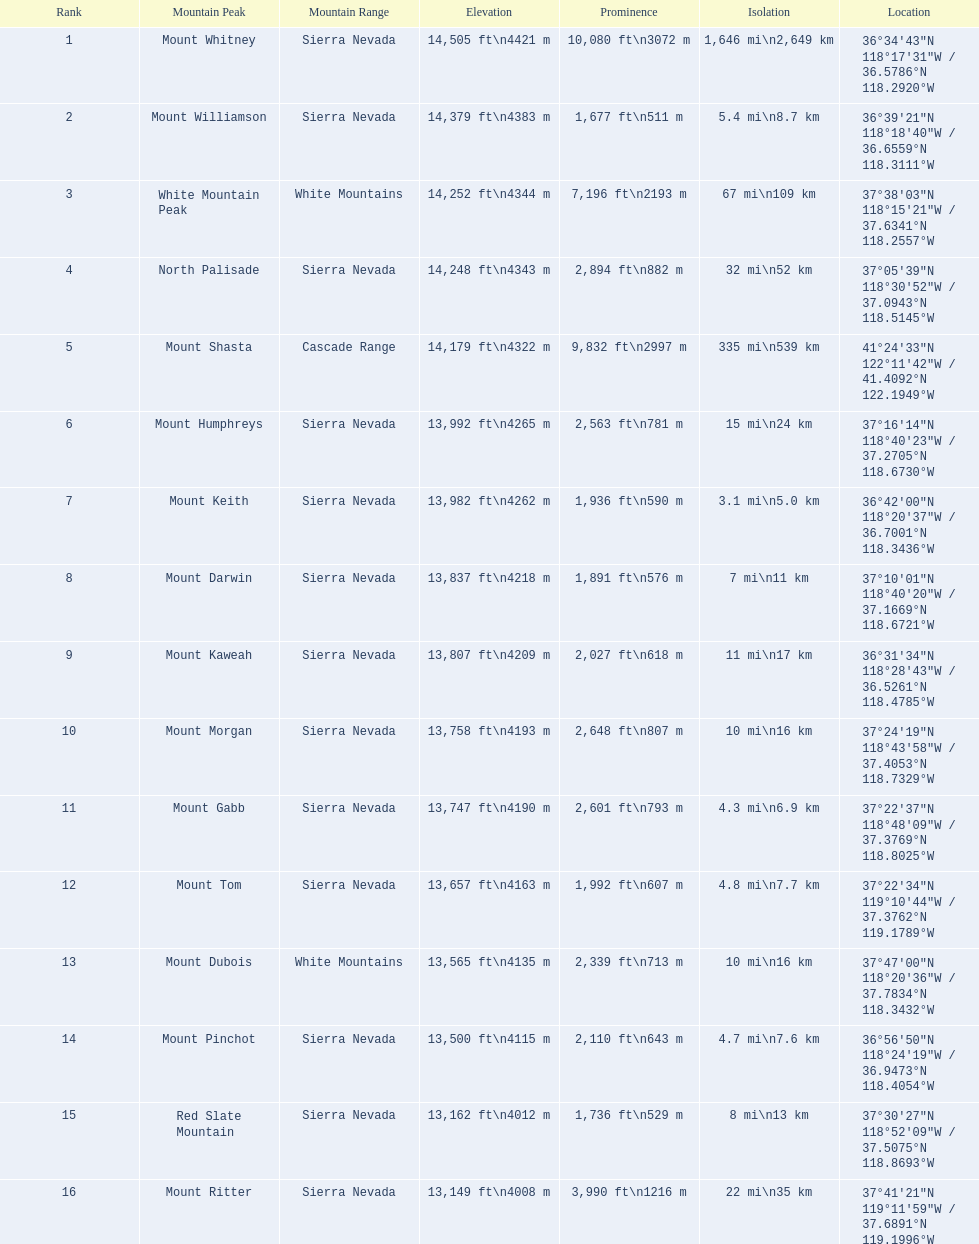What are the mountain peaks? Mount Whitney, Mount Williamson, White Mountain Peak, North Palisade, Mount Shasta, Mount Humphreys, Mount Keith, Mount Darwin, Mount Kaweah, Mount Morgan, Mount Gabb, Mount Tom, Mount Dubois, Mount Pinchot, Red Slate Mountain, Mount Ritter. Of these, which one has a prominence more than 10,000 ft? Mount Whitney. 